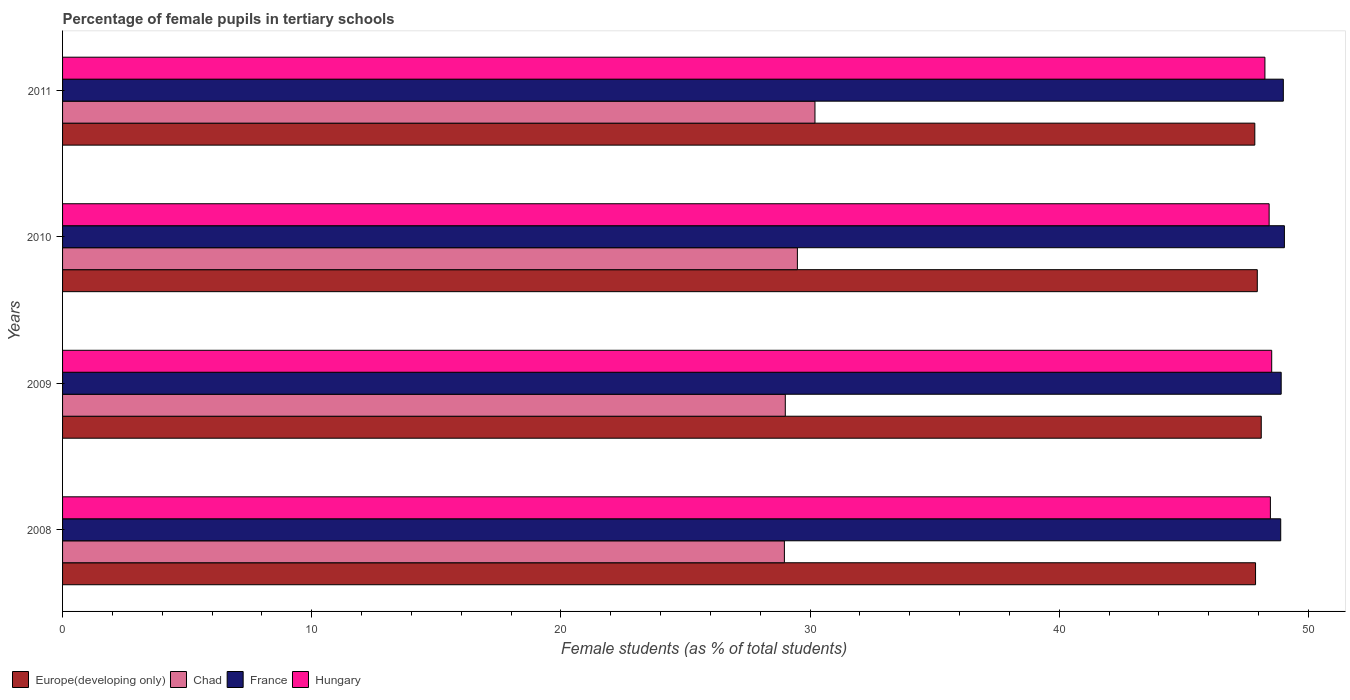How many different coloured bars are there?
Offer a very short reply. 4. How many groups of bars are there?
Your answer should be very brief. 4. What is the label of the 3rd group of bars from the top?
Offer a terse response. 2009. In how many cases, is the number of bars for a given year not equal to the number of legend labels?
Your answer should be compact. 0. What is the percentage of female pupils in tertiary schools in Europe(developing only) in 2010?
Give a very brief answer. 47.95. Across all years, what is the maximum percentage of female pupils in tertiary schools in Hungary?
Ensure brevity in your answer.  48.53. Across all years, what is the minimum percentage of female pupils in tertiary schools in Hungary?
Your answer should be very brief. 48.26. In which year was the percentage of female pupils in tertiary schools in Europe(developing only) minimum?
Offer a terse response. 2011. What is the total percentage of female pupils in tertiary schools in France in the graph?
Your answer should be compact. 195.84. What is the difference between the percentage of female pupils in tertiary schools in Chad in 2009 and that in 2010?
Offer a very short reply. -0.49. What is the difference between the percentage of female pupils in tertiary schools in Chad in 2009 and the percentage of female pupils in tertiary schools in France in 2011?
Keep it short and to the point. -19.99. What is the average percentage of female pupils in tertiary schools in Chad per year?
Provide a short and direct response. 29.42. In the year 2009, what is the difference between the percentage of female pupils in tertiary schools in Europe(developing only) and percentage of female pupils in tertiary schools in Hungary?
Give a very brief answer. -0.42. In how many years, is the percentage of female pupils in tertiary schools in Chad greater than 28 %?
Provide a succinct answer. 4. What is the ratio of the percentage of female pupils in tertiary schools in Hungary in 2010 to that in 2011?
Ensure brevity in your answer.  1. Is the percentage of female pupils in tertiary schools in Hungary in 2009 less than that in 2011?
Make the answer very short. No. Is the difference between the percentage of female pupils in tertiary schools in Europe(developing only) in 2008 and 2010 greater than the difference between the percentage of female pupils in tertiary schools in Hungary in 2008 and 2010?
Your answer should be very brief. No. What is the difference between the highest and the second highest percentage of female pupils in tertiary schools in Hungary?
Provide a succinct answer. 0.05. What is the difference between the highest and the lowest percentage of female pupils in tertiary schools in Chad?
Make the answer very short. 1.23. In how many years, is the percentage of female pupils in tertiary schools in Hungary greater than the average percentage of female pupils in tertiary schools in Hungary taken over all years?
Provide a short and direct response. 3. Is it the case that in every year, the sum of the percentage of female pupils in tertiary schools in Chad and percentage of female pupils in tertiary schools in Hungary is greater than the sum of percentage of female pupils in tertiary schools in France and percentage of female pupils in tertiary schools in Europe(developing only)?
Your answer should be compact. No. How many bars are there?
Your answer should be very brief. 16. How many years are there in the graph?
Offer a very short reply. 4. How many legend labels are there?
Your response must be concise. 4. What is the title of the graph?
Offer a very short reply. Percentage of female pupils in tertiary schools. What is the label or title of the X-axis?
Give a very brief answer. Female students (as % of total students). What is the Female students (as % of total students) of Europe(developing only) in 2008?
Your answer should be compact. 47.88. What is the Female students (as % of total students) of Chad in 2008?
Provide a succinct answer. 28.97. What is the Female students (as % of total students) in France in 2008?
Make the answer very short. 48.89. What is the Female students (as % of total students) in Hungary in 2008?
Your response must be concise. 48.48. What is the Female students (as % of total students) in Europe(developing only) in 2009?
Keep it short and to the point. 48.11. What is the Female students (as % of total students) of Chad in 2009?
Provide a succinct answer. 29.01. What is the Female students (as % of total students) in France in 2009?
Provide a succinct answer. 48.91. What is the Female students (as % of total students) of Hungary in 2009?
Make the answer very short. 48.53. What is the Female students (as % of total students) of Europe(developing only) in 2010?
Provide a succinct answer. 47.95. What is the Female students (as % of total students) in Chad in 2010?
Your answer should be compact. 29.49. What is the Female students (as % of total students) in France in 2010?
Keep it short and to the point. 49.04. What is the Female students (as % of total students) of Hungary in 2010?
Your answer should be very brief. 48.43. What is the Female students (as % of total students) in Europe(developing only) in 2011?
Keep it short and to the point. 47.85. What is the Female students (as % of total students) of Chad in 2011?
Give a very brief answer. 30.2. What is the Female students (as % of total students) in France in 2011?
Give a very brief answer. 49. What is the Female students (as % of total students) in Hungary in 2011?
Give a very brief answer. 48.26. Across all years, what is the maximum Female students (as % of total students) of Europe(developing only)?
Give a very brief answer. 48.11. Across all years, what is the maximum Female students (as % of total students) in Chad?
Keep it short and to the point. 30.2. Across all years, what is the maximum Female students (as % of total students) in France?
Your answer should be compact. 49.04. Across all years, what is the maximum Female students (as % of total students) in Hungary?
Your response must be concise. 48.53. Across all years, what is the minimum Female students (as % of total students) of Europe(developing only)?
Ensure brevity in your answer.  47.85. Across all years, what is the minimum Female students (as % of total students) in Chad?
Your response must be concise. 28.97. Across all years, what is the minimum Female students (as % of total students) of France?
Your response must be concise. 48.89. Across all years, what is the minimum Female students (as % of total students) of Hungary?
Give a very brief answer. 48.26. What is the total Female students (as % of total students) in Europe(developing only) in the graph?
Offer a very short reply. 191.79. What is the total Female students (as % of total students) of Chad in the graph?
Provide a succinct answer. 117.67. What is the total Female students (as % of total students) in France in the graph?
Offer a terse response. 195.84. What is the total Female students (as % of total students) in Hungary in the graph?
Provide a succinct answer. 193.69. What is the difference between the Female students (as % of total students) in Europe(developing only) in 2008 and that in 2009?
Offer a terse response. -0.23. What is the difference between the Female students (as % of total students) in Chad in 2008 and that in 2009?
Offer a very short reply. -0.04. What is the difference between the Female students (as % of total students) of France in 2008 and that in 2009?
Your answer should be compact. -0.02. What is the difference between the Female students (as % of total students) in Hungary in 2008 and that in 2009?
Provide a short and direct response. -0.05. What is the difference between the Female students (as % of total students) in Europe(developing only) in 2008 and that in 2010?
Make the answer very short. -0.07. What is the difference between the Female students (as % of total students) of Chad in 2008 and that in 2010?
Ensure brevity in your answer.  -0.52. What is the difference between the Female students (as % of total students) in France in 2008 and that in 2010?
Provide a short and direct response. -0.15. What is the difference between the Female students (as % of total students) in Hungary in 2008 and that in 2010?
Your response must be concise. 0.05. What is the difference between the Female students (as % of total students) of Europe(developing only) in 2008 and that in 2011?
Provide a short and direct response. 0.03. What is the difference between the Female students (as % of total students) in Chad in 2008 and that in 2011?
Provide a short and direct response. -1.23. What is the difference between the Female students (as % of total students) of France in 2008 and that in 2011?
Your answer should be compact. -0.11. What is the difference between the Female students (as % of total students) in Hungary in 2008 and that in 2011?
Provide a short and direct response. 0.22. What is the difference between the Female students (as % of total students) in Europe(developing only) in 2009 and that in 2010?
Provide a succinct answer. 0.16. What is the difference between the Female students (as % of total students) of Chad in 2009 and that in 2010?
Keep it short and to the point. -0.49. What is the difference between the Female students (as % of total students) of France in 2009 and that in 2010?
Provide a short and direct response. -0.13. What is the difference between the Female students (as % of total students) in Hungary in 2009 and that in 2010?
Offer a very short reply. 0.1. What is the difference between the Female students (as % of total students) of Europe(developing only) in 2009 and that in 2011?
Your response must be concise. 0.26. What is the difference between the Female students (as % of total students) of Chad in 2009 and that in 2011?
Offer a terse response. -1.19. What is the difference between the Female students (as % of total students) of France in 2009 and that in 2011?
Keep it short and to the point. -0.09. What is the difference between the Female students (as % of total students) in Hungary in 2009 and that in 2011?
Your answer should be very brief. 0.27. What is the difference between the Female students (as % of total students) in Europe(developing only) in 2010 and that in 2011?
Your response must be concise. 0.1. What is the difference between the Female students (as % of total students) of Chad in 2010 and that in 2011?
Ensure brevity in your answer.  -0.71. What is the difference between the Female students (as % of total students) of France in 2010 and that in 2011?
Keep it short and to the point. 0.04. What is the difference between the Female students (as % of total students) of Hungary in 2010 and that in 2011?
Your answer should be very brief. 0.17. What is the difference between the Female students (as % of total students) of Europe(developing only) in 2008 and the Female students (as % of total students) of Chad in 2009?
Offer a very short reply. 18.87. What is the difference between the Female students (as % of total students) in Europe(developing only) in 2008 and the Female students (as % of total students) in France in 2009?
Your answer should be compact. -1.03. What is the difference between the Female students (as % of total students) of Europe(developing only) in 2008 and the Female students (as % of total students) of Hungary in 2009?
Your response must be concise. -0.65. What is the difference between the Female students (as % of total students) in Chad in 2008 and the Female students (as % of total students) in France in 2009?
Give a very brief answer. -19.94. What is the difference between the Female students (as % of total students) in Chad in 2008 and the Female students (as % of total students) in Hungary in 2009?
Your answer should be very brief. -19.56. What is the difference between the Female students (as % of total students) of France in 2008 and the Female students (as % of total students) of Hungary in 2009?
Your answer should be compact. 0.36. What is the difference between the Female students (as % of total students) of Europe(developing only) in 2008 and the Female students (as % of total students) of Chad in 2010?
Ensure brevity in your answer.  18.39. What is the difference between the Female students (as % of total students) of Europe(developing only) in 2008 and the Female students (as % of total students) of France in 2010?
Offer a terse response. -1.16. What is the difference between the Female students (as % of total students) of Europe(developing only) in 2008 and the Female students (as % of total students) of Hungary in 2010?
Ensure brevity in your answer.  -0.55. What is the difference between the Female students (as % of total students) in Chad in 2008 and the Female students (as % of total students) in France in 2010?
Keep it short and to the point. -20.07. What is the difference between the Female students (as % of total students) of Chad in 2008 and the Female students (as % of total students) of Hungary in 2010?
Your response must be concise. -19.46. What is the difference between the Female students (as % of total students) in France in 2008 and the Female students (as % of total students) in Hungary in 2010?
Give a very brief answer. 0.46. What is the difference between the Female students (as % of total students) in Europe(developing only) in 2008 and the Female students (as % of total students) in Chad in 2011?
Your answer should be very brief. 17.68. What is the difference between the Female students (as % of total students) of Europe(developing only) in 2008 and the Female students (as % of total students) of France in 2011?
Ensure brevity in your answer.  -1.11. What is the difference between the Female students (as % of total students) in Europe(developing only) in 2008 and the Female students (as % of total students) in Hungary in 2011?
Your answer should be very brief. -0.38. What is the difference between the Female students (as % of total students) in Chad in 2008 and the Female students (as % of total students) in France in 2011?
Your response must be concise. -20.03. What is the difference between the Female students (as % of total students) of Chad in 2008 and the Female students (as % of total students) of Hungary in 2011?
Ensure brevity in your answer.  -19.29. What is the difference between the Female students (as % of total students) in France in 2008 and the Female students (as % of total students) in Hungary in 2011?
Your answer should be compact. 0.63. What is the difference between the Female students (as % of total students) of Europe(developing only) in 2009 and the Female students (as % of total students) of Chad in 2010?
Your response must be concise. 18.62. What is the difference between the Female students (as % of total students) of Europe(developing only) in 2009 and the Female students (as % of total students) of France in 2010?
Give a very brief answer. -0.93. What is the difference between the Female students (as % of total students) in Europe(developing only) in 2009 and the Female students (as % of total students) in Hungary in 2010?
Keep it short and to the point. -0.32. What is the difference between the Female students (as % of total students) in Chad in 2009 and the Female students (as % of total students) in France in 2010?
Ensure brevity in your answer.  -20.03. What is the difference between the Female students (as % of total students) in Chad in 2009 and the Female students (as % of total students) in Hungary in 2010?
Your response must be concise. -19.42. What is the difference between the Female students (as % of total students) of France in 2009 and the Female students (as % of total students) of Hungary in 2010?
Your answer should be very brief. 0.48. What is the difference between the Female students (as % of total students) in Europe(developing only) in 2009 and the Female students (as % of total students) in Chad in 2011?
Give a very brief answer. 17.91. What is the difference between the Female students (as % of total students) of Europe(developing only) in 2009 and the Female students (as % of total students) of France in 2011?
Your response must be concise. -0.89. What is the difference between the Female students (as % of total students) of Europe(developing only) in 2009 and the Female students (as % of total students) of Hungary in 2011?
Offer a terse response. -0.15. What is the difference between the Female students (as % of total students) of Chad in 2009 and the Female students (as % of total students) of France in 2011?
Your response must be concise. -19.99. What is the difference between the Female students (as % of total students) of Chad in 2009 and the Female students (as % of total students) of Hungary in 2011?
Provide a succinct answer. -19.25. What is the difference between the Female students (as % of total students) of France in 2009 and the Female students (as % of total students) of Hungary in 2011?
Provide a succinct answer. 0.65. What is the difference between the Female students (as % of total students) of Europe(developing only) in 2010 and the Female students (as % of total students) of Chad in 2011?
Provide a short and direct response. 17.75. What is the difference between the Female students (as % of total students) of Europe(developing only) in 2010 and the Female students (as % of total students) of France in 2011?
Your answer should be compact. -1.04. What is the difference between the Female students (as % of total students) in Europe(developing only) in 2010 and the Female students (as % of total students) in Hungary in 2011?
Make the answer very short. -0.31. What is the difference between the Female students (as % of total students) of Chad in 2010 and the Female students (as % of total students) of France in 2011?
Your response must be concise. -19.5. What is the difference between the Female students (as % of total students) of Chad in 2010 and the Female students (as % of total students) of Hungary in 2011?
Your response must be concise. -18.76. What is the difference between the Female students (as % of total students) in France in 2010 and the Female students (as % of total students) in Hungary in 2011?
Keep it short and to the point. 0.78. What is the average Female students (as % of total students) of Europe(developing only) per year?
Make the answer very short. 47.95. What is the average Female students (as % of total students) in Chad per year?
Make the answer very short. 29.42. What is the average Female students (as % of total students) of France per year?
Provide a short and direct response. 48.96. What is the average Female students (as % of total students) of Hungary per year?
Your answer should be compact. 48.42. In the year 2008, what is the difference between the Female students (as % of total students) of Europe(developing only) and Female students (as % of total students) of Chad?
Provide a short and direct response. 18.91. In the year 2008, what is the difference between the Female students (as % of total students) of Europe(developing only) and Female students (as % of total students) of France?
Your answer should be compact. -1.01. In the year 2008, what is the difference between the Female students (as % of total students) of Europe(developing only) and Female students (as % of total students) of Hungary?
Give a very brief answer. -0.6. In the year 2008, what is the difference between the Female students (as % of total students) in Chad and Female students (as % of total students) in France?
Offer a very short reply. -19.92. In the year 2008, what is the difference between the Female students (as % of total students) in Chad and Female students (as % of total students) in Hungary?
Make the answer very short. -19.51. In the year 2008, what is the difference between the Female students (as % of total students) in France and Female students (as % of total students) in Hungary?
Your response must be concise. 0.41. In the year 2009, what is the difference between the Female students (as % of total students) in Europe(developing only) and Female students (as % of total students) in Chad?
Your answer should be compact. 19.1. In the year 2009, what is the difference between the Female students (as % of total students) of Europe(developing only) and Female students (as % of total students) of France?
Your answer should be compact. -0.8. In the year 2009, what is the difference between the Female students (as % of total students) in Europe(developing only) and Female students (as % of total students) in Hungary?
Ensure brevity in your answer.  -0.42. In the year 2009, what is the difference between the Female students (as % of total students) of Chad and Female students (as % of total students) of France?
Your response must be concise. -19.9. In the year 2009, what is the difference between the Female students (as % of total students) in Chad and Female students (as % of total students) in Hungary?
Your answer should be compact. -19.52. In the year 2009, what is the difference between the Female students (as % of total students) of France and Female students (as % of total students) of Hungary?
Offer a very short reply. 0.38. In the year 2010, what is the difference between the Female students (as % of total students) of Europe(developing only) and Female students (as % of total students) of Chad?
Your answer should be very brief. 18.46. In the year 2010, what is the difference between the Female students (as % of total students) in Europe(developing only) and Female students (as % of total students) in France?
Keep it short and to the point. -1.09. In the year 2010, what is the difference between the Female students (as % of total students) of Europe(developing only) and Female students (as % of total students) of Hungary?
Keep it short and to the point. -0.47. In the year 2010, what is the difference between the Female students (as % of total students) of Chad and Female students (as % of total students) of France?
Provide a succinct answer. -19.55. In the year 2010, what is the difference between the Female students (as % of total students) in Chad and Female students (as % of total students) in Hungary?
Give a very brief answer. -18.93. In the year 2010, what is the difference between the Female students (as % of total students) of France and Female students (as % of total students) of Hungary?
Provide a succinct answer. 0.61. In the year 2011, what is the difference between the Female students (as % of total students) in Europe(developing only) and Female students (as % of total students) in Chad?
Provide a succinct answer. 17.65. In the year 2011, what is the difference between the Female students (as % of total students) in Europe(developing only) and Female students (as % of total students) in France?
Provide a short and direct response. -1.14. In the year 2011, what is the difference between the Female students (as % of total students) of Europe(developing only) and Female students (as % of total students) of Hungary?
Provide a succinct answer. -0.41. In the year 2011, what is the difference between the Female students (as % of total students) in Chad and Female students (as % of total students) in France?
Provide a succinct answer. -18.8. In the year 2011, what is the difference between the Female students (as % of total students) of Chad and Female students (as % of total students) of Hungary?
Your answer should be very brief. -18.06. In the year 2011, what is the difference between the Female students (as % of total students) of France and Female students (as % of total students) of Hungary?
Offer a very short reply. 0.74. What is the ratio of the Female students (as % of total students) in Europe(developing only) in 2008 to that in 2009?
Your answer should be very brief. 1. What is the ratio of the Female students (as % of total students) of France in 2008 to that in 2009?
Your answer should be very brief. 1. What is the ratio of the Female students (as % of total students) in Europe(developing only) in 2008 to that in 2010?
Make the answer very short. 1. What is the ratio of the Female students (as % of total students) in Chad in 2008 to that in 2010?
Give a very brief answer. 0.98. What is the ratio of the Female students (as % of total students) of Hungary in 2008 to that in 2010?
Your answer should be compact. 1. What is the ratio of the Female students (as % of total students) in Europe(developing only) in 2008 to that in 2011?
Provide a succinct answer. 1. What is the ratio of the Female students (as % of total students) in Chad in 2008 to that in 2011?
Your response must be concise. 0.96. What is the ratio of the Female students (as % of total students) in France in 2008 to that in 2011?
Give a very brief answer. 1. What is the ratio of the Female students (as % of total students) of Chad in 2009 to that in 2010?
Offer a terse response. 0.98. What is the ratio of the Female students (as % of total students) of Hungary in 2009 to that in 2010?
Offer a very short reply. 1. What is the ratio of the Female students (as % of total students) in Europe(developing only) in 2009 to that in 2011?
Give a very brief answer. 1.01. What is the ratio of the Female students (as % of total students) in Chad in 2009 to that in 2011?
Your answer should be compact. 0.96. What is the ratio of the Female students (as % of total students) in Hungary in 2009 to that in 2011?
Keep it short and to the point. 1.01. What is the ratio of the Female students (as % of total students) of Chad in 2010 to that in 2011?
Offer a terse response. 0.98. What is the ratio of the Female students (as % of total students) in France in 2010 to that in 2011?
Give a very brief answer. 1. What is the difference between the highest and the second highest Female students (as % of total students) in Europe(developing only)?
Give a very brief answer. 0.16. What is the difference between the highest and the second highest Female students (as % of total students) in Chad?
Provide a short and direct response. 0.71. What is the difference between the highest and the second highest Female students (as % of total students) in France?
Provide a succinct answer. 0.04. What is the difference between the highest and the second highest Female students (as % of total students) in Hungary?
Make the answer very short. 0.05. What is the difference between the highest and the lowest Female students (as % of total students) of Europe(developing only)?
Provide a succinct answer. 0.26. What is the difference between the highest and the lowest Female students (as % of total students) in Chad?
Your answer should be very brief. 1.23. What is the difference between the highest and the lowest Female students (as % of total students) in France?
Give a very brief answer. 0.15. What is the difference between the highest and the lowest Female students (as % of total students) in Hungary?
Your answer should be very brief. 0.27. 